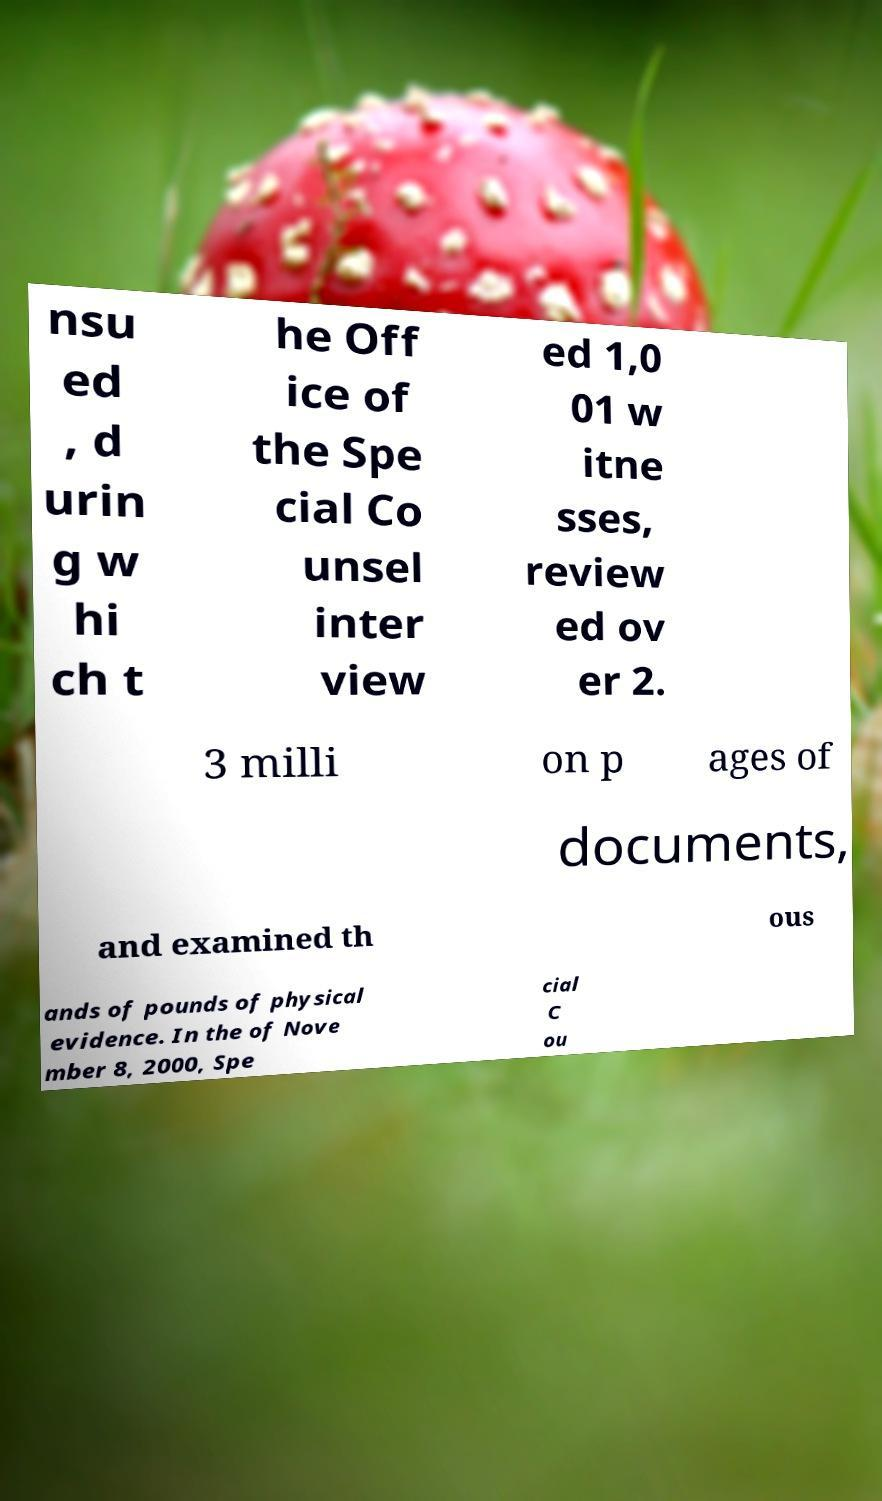There's text embedded in this image that I need extracted. Can you transcribe it verbatim? nsu ed , d urin g w hi ch t he Off ice of the Spe cial Co unsel inter view ed 1,0 01 w itne sses, review ed ov er 2. 3 milli on p ages of documents, and examined th ous ands of pounds of physical evidence. In the of Nove mber 8, 2000, Spe cial C ou 